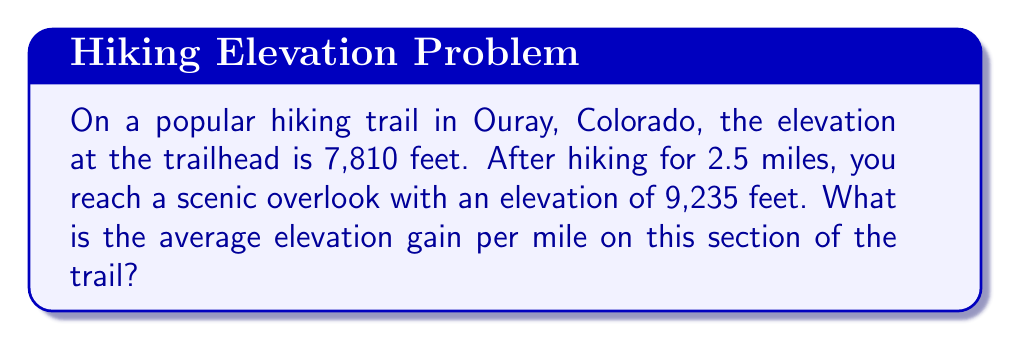Can you solve this math problem? To solve this problem, we'll follow these steps:

1. Calculate the total elevation gain:
   $$\text{Elevation gain} = \text{Final elevation} - \text{Initial elevation}$$
   $$\text{Elevation gain} = 9,235 \text{ ft} - 7,810 \text{ ft} = 1,425 \text{ ft}$$

2. Determine the distance hiked:
   The distance is given as 2.5 miles.

3. Calculate the average elevation gain per mile:
   $$\text{Average elevation gain per mile} = \frac{\text{Total elevation gain}}{\text{Distance hiked}}$$
   $$\text{Average elevation gain per mile} = \frac{1,425 \text{ ft}}{2.5 \text{ miles}}$$
   $$\text{Average elevation gain per mile} = 570 \text{ ft/mile}$$

Therefore, the average elevation gain per mile on this section of the trail is 570 feet per mile.
Answer: 570 ft/mile 